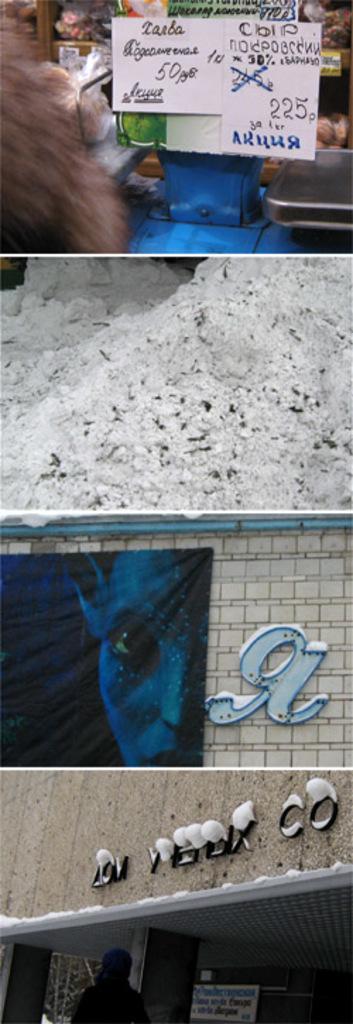How would you summarize this image in a sentence or two? This is a photo grid image, on the top image having a label board with groceries behind it on shelves and below it, the image having pile of white powder and below there is a poster of alien on the wall, on the bottom image there is a person walking in front of a building. 